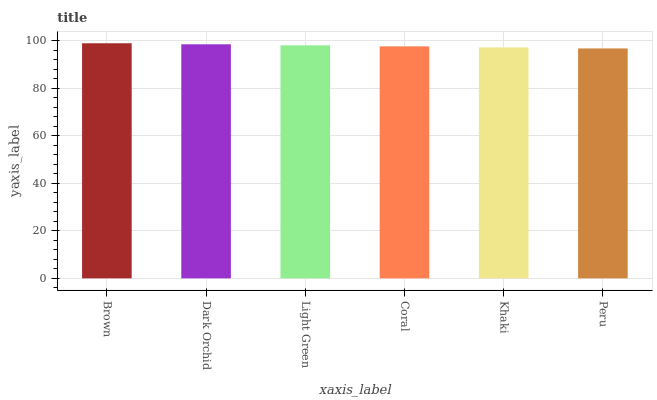Is Peru the minimum?
Answer yes or no. Yes. Is Brown the maximum?
Answer yes or no. Yes. Is Dark Orchid the minimum?
Answer yes or no. No. Is Dark Orchid the maximum?
Answer yes or no. No. Is Brown greater than Dark Orchid?
Answer yes or no. Yes. Is Dark Orchid less than Brown?
Answer yes or no. Yes. Is Dark Orchid greater than Brown?
Answer yes or no. No. Is Brown less than Dark Orchid?
Answer yes or no. No. Is Light Green the high median?
Answer yes or no. Yes. Is Coral the low median?
Answer yes or no. Yes. Is Coral the high median?
Answer yes or no. No. Is Peru the low median?
Answer yes or no. No. 